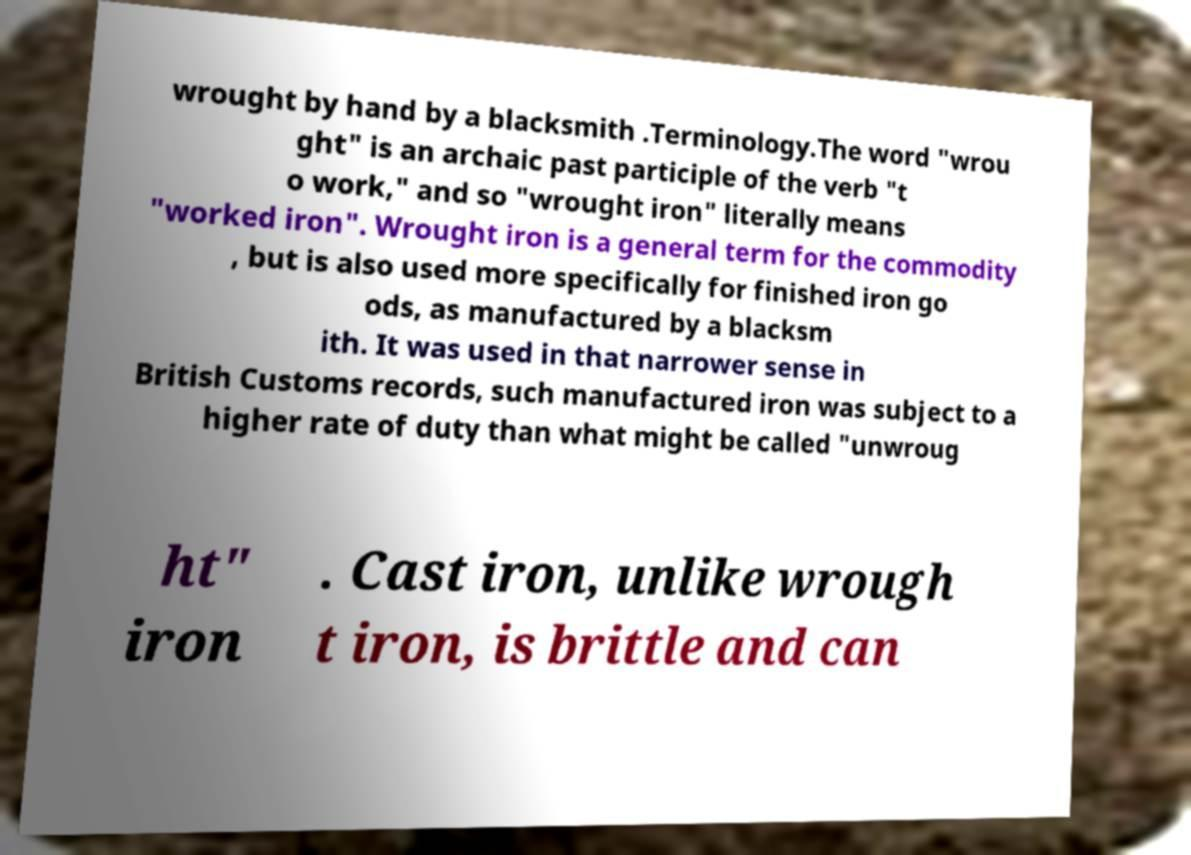Could you extract and type out the text from this image? wrought by hand by a blacksmith .Terminology.The word "wrou ght" is an archaic past participle of the verb "t o work," and so "wrought iron" literally means "worked iron". Wrought iron is a general term for the commodity , but is also used more specifically for finished iron go ods, as manufactured by a blacksm ith. It was used in that narrower sense in British Customs records, such manufactured iron was subject to a higher rate of duty than what might be called "unwroug ht" iron . Cast iron, unlike wrough t iron, is brittle and can 